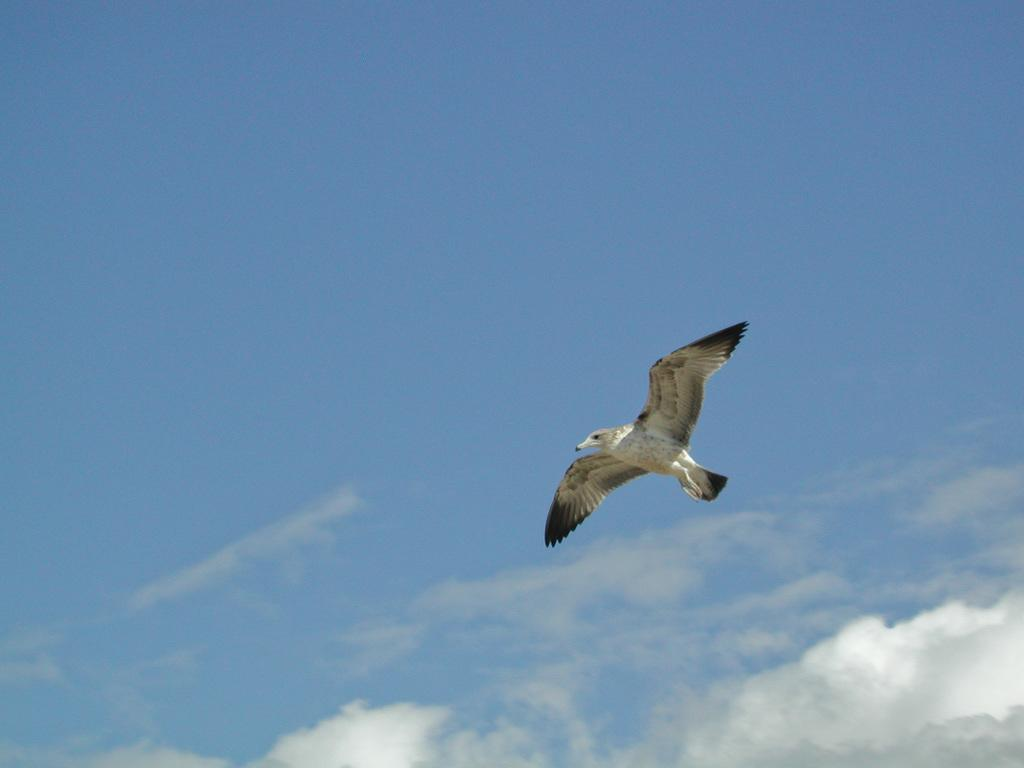What type of animal can be seen in the image? There is a bird in the image. What is the bird doing in the image? The bird is flying in the sky. What type of feast is being prepared in the image? There is no feast present in the image; it only features a bird flying in the sky. Can you see any planes in the image? There are no planes visible in the image; it only features a bird flying in the sky. 